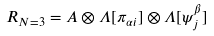<formula> <loc_0><loc_0><loc_500><loc_500>R _ { N = 3 } = A \otimes \Lambda [ \pi _ { \alpha i } ] \otimes \Lambda [ \psi ^ { \beta } _ { j } ]</formula> 